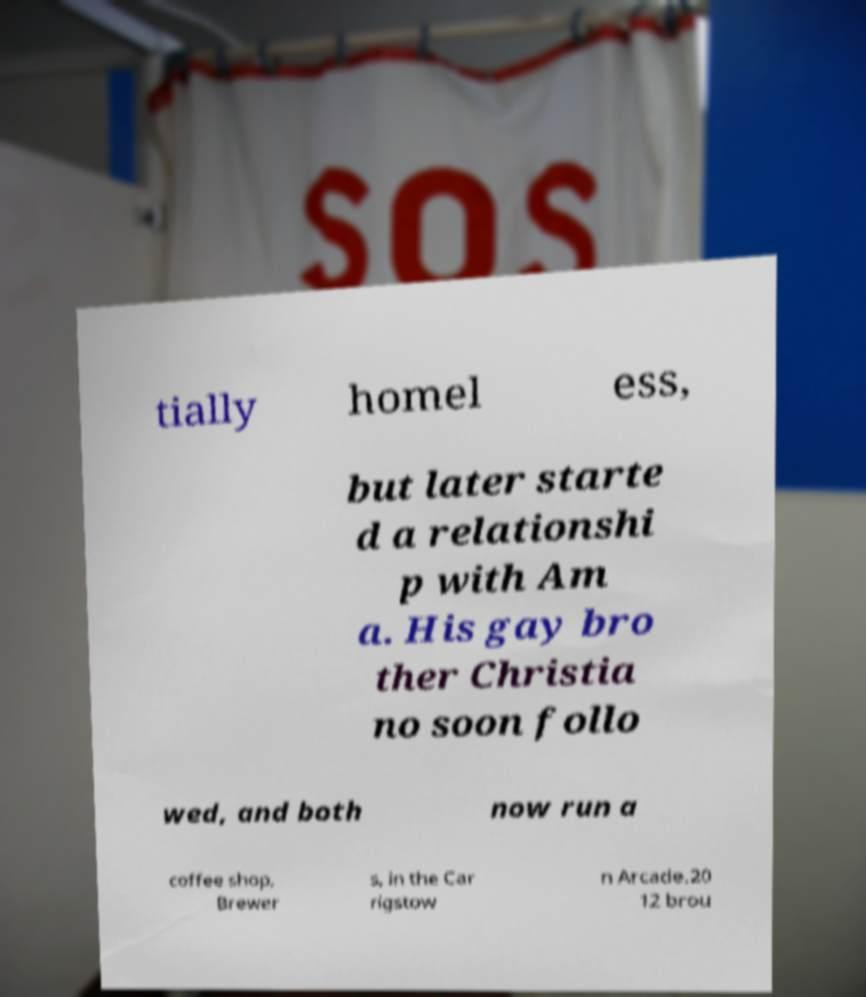Can you accurately transcribe the text from the provided image for me? tially homel ess, but later starte d a relationshi p with Am a. His gay bro ther Christia no soon follo wed, and both now run a coffee shop, Brewer s, in the Car rigstow n Arcade.20 12 brou 